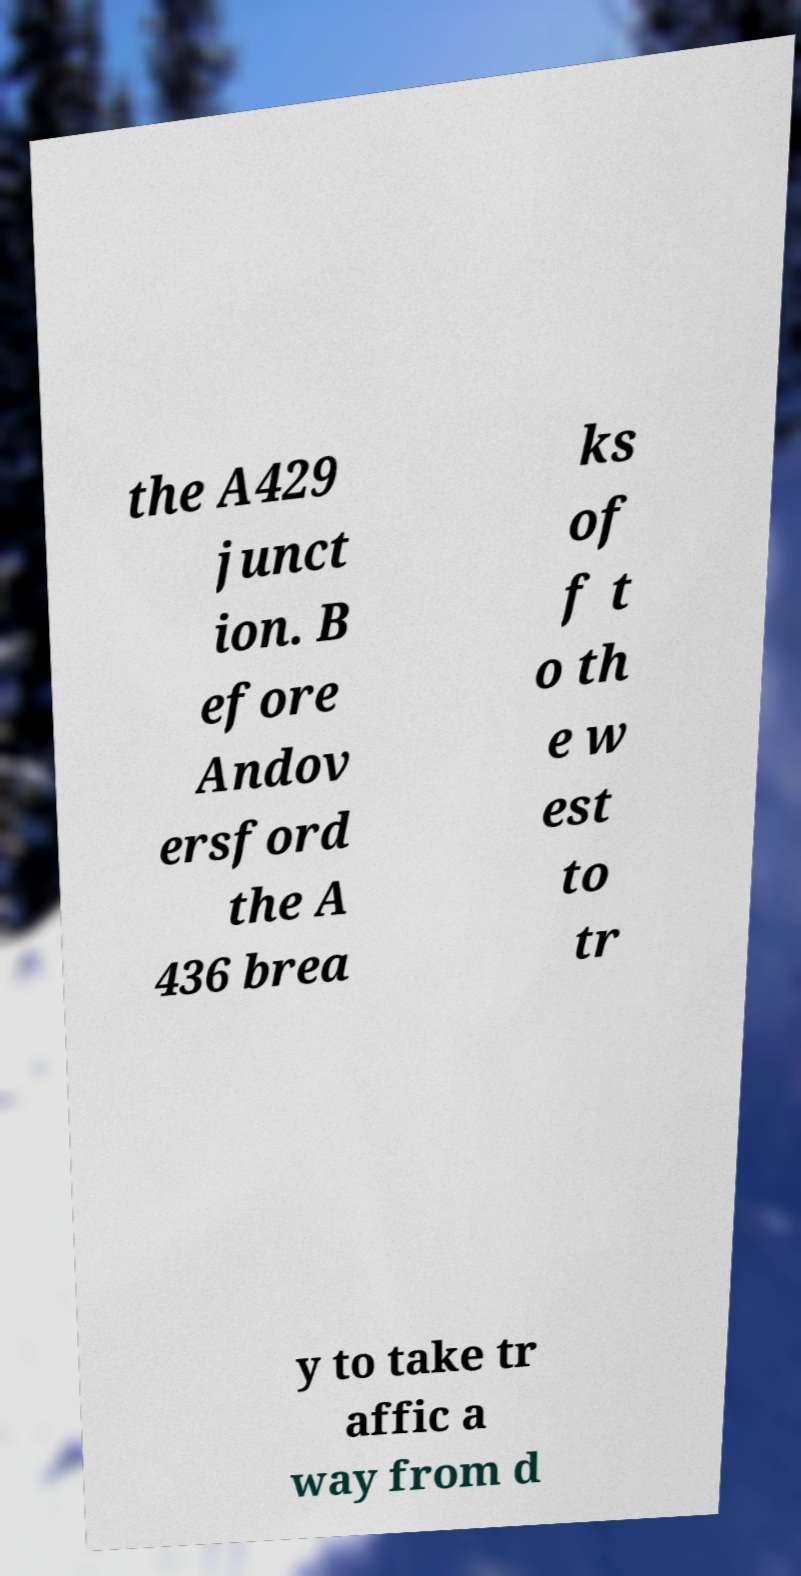Can you accurately transcribe the text from the provided image for me? the A429 junct ion. B efore Andov ersford the A 436 brea ks of f t o th e w est to tr y to take tr affic a way from d 